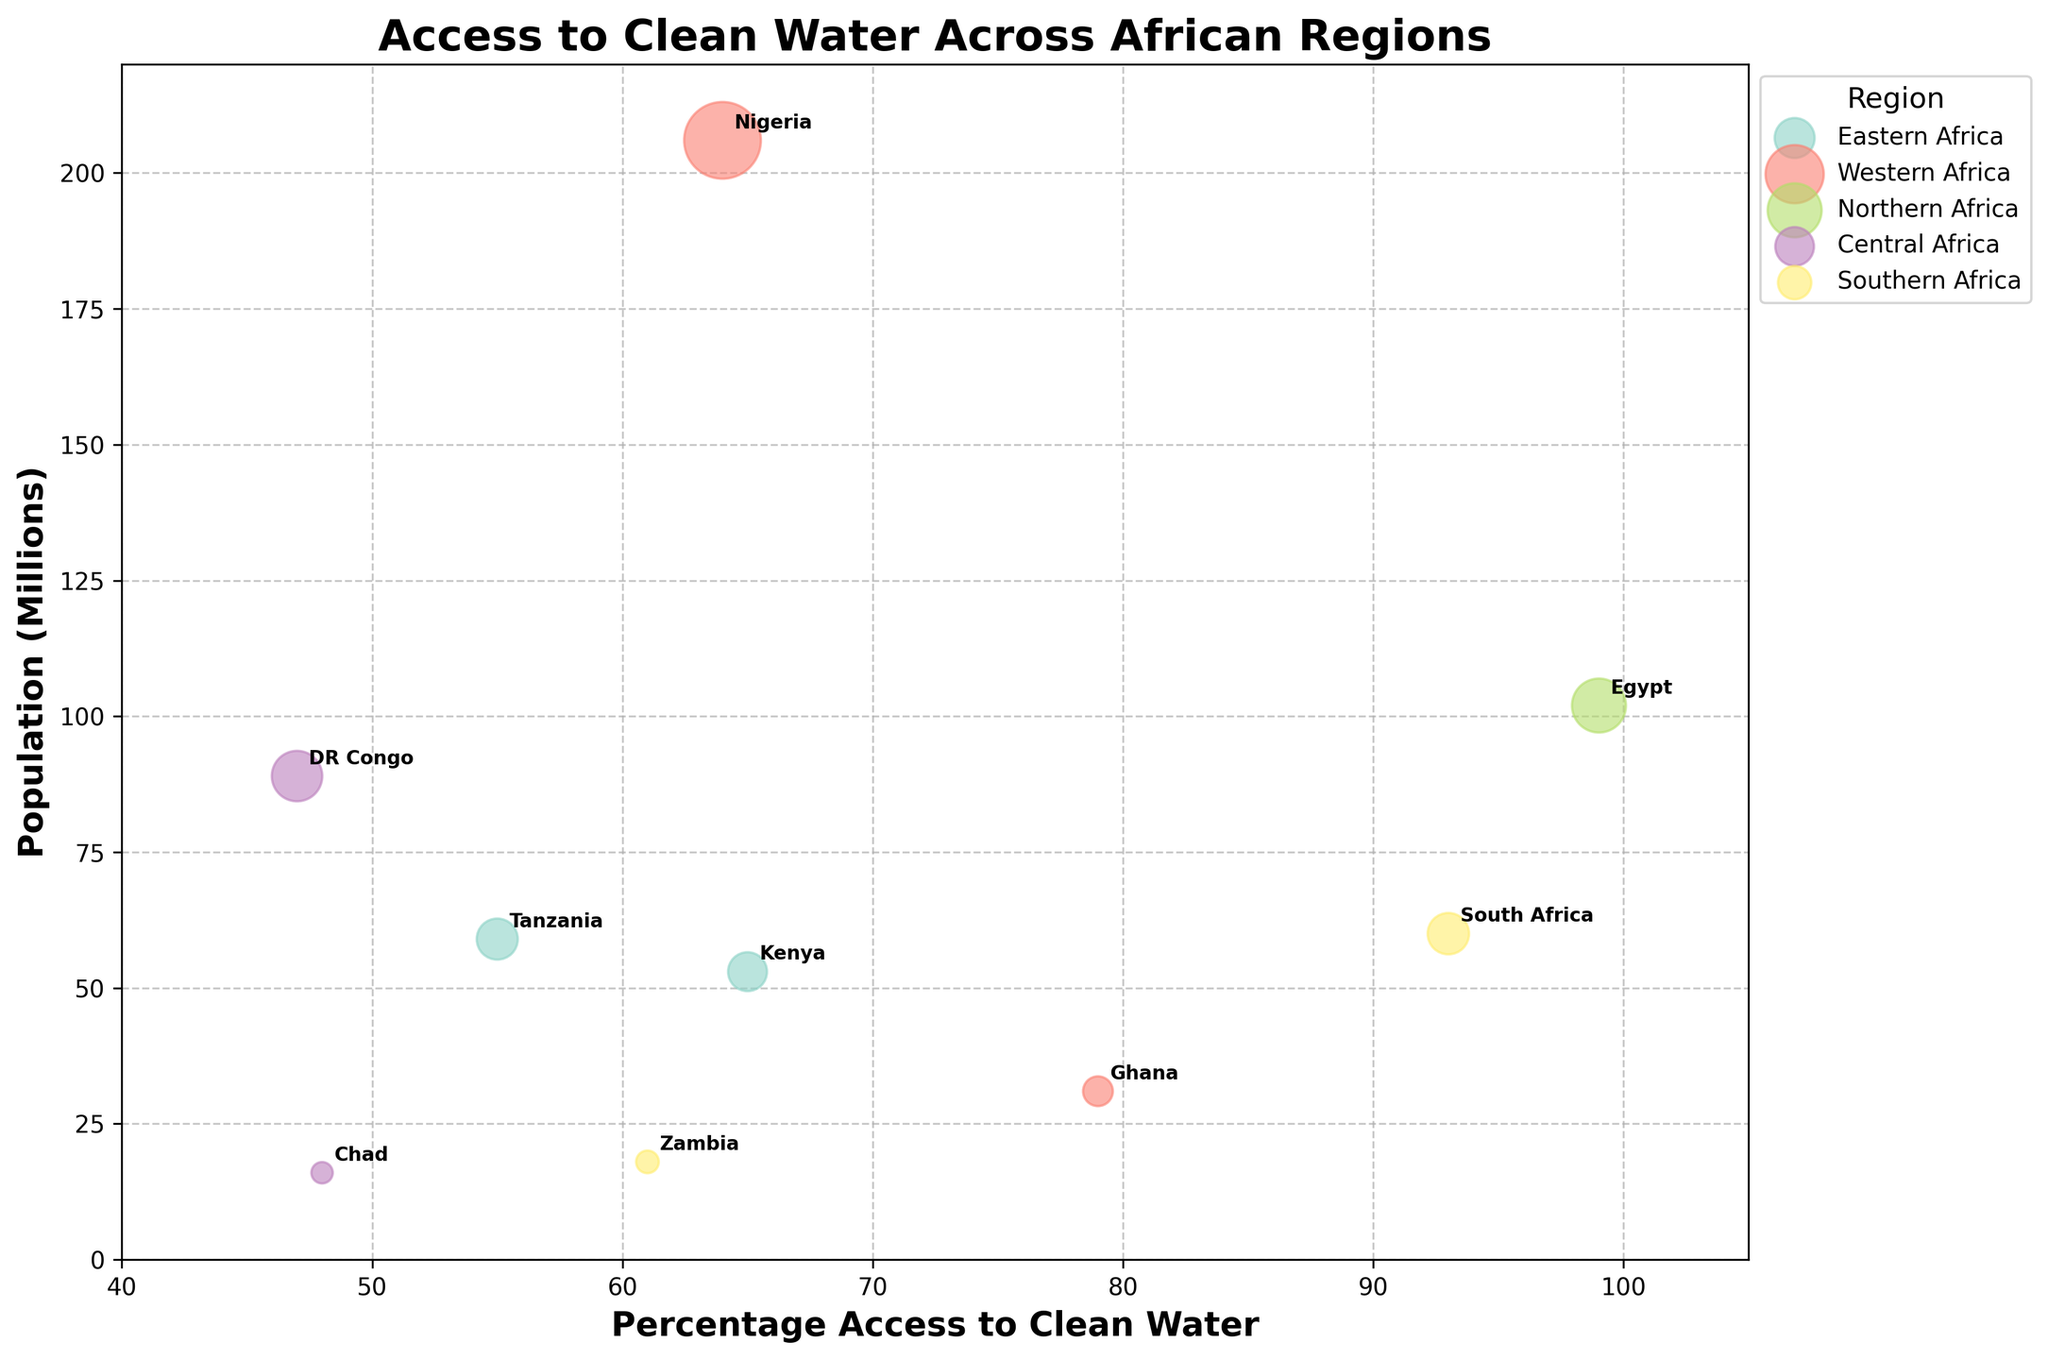What is the title of the figure? The title of the figure is found at the top of the chart, giving an overview of what the data represents. Here, it reads "Access to Clean Water Across African Regions."
Answer: Access to Clean Water Across African Regions How many regions are represented in the chart? By looking at the legend, you can see each distinct color represents a unique region. Counting the different regions listed, there are five.
Answer: Five Which country has the highest percentage of access to clean water? By locating the highest value on the x-axis (Percentage Access to Clean Water) and checking the corresponding bubble, Egypt has the highest value at 99%.
Answer: Egypt What is the population size of South Africa? Find the bubble labeled "South Africa" and read the corresponding y-axis value for Population (Millions), which is around 60 million.
Answer: 60 million Which two countries from Eastern Africa are shown? Look at the legend to identify the color for Eastern Africa, then find the corresponding bubbles. The countries are labeled as "Kenya" and "Tanzania."
Answer: Kenya and Tanzania What is the average percentage access to clean water in Western Africa? First, identify the countries in Western Africa: Nigeria (64) and Ghana (79). Add these percentages: 64 + 79 = 143. Then, divide by the number of countries: 143 / 2 = 71.5
Answer: 71.5% Which region has the lowest average access to clean water? Calculate the average for each region: 
Eastern Africa (65+55)/2 = 60;
Western Africa (64+79)/2 = 71.5;
Northern Africa (99);
Central Africa (48+47)/2 = 47.5;
Southern Africa (93+61)/2 = 77.
Among these, Central Africa has the lowest average (47.5).
Answer: Central Africa How is the size of the bubbles determined? The size of the bubbles corresponds to the Population in Millions for each country, with larger populations resulting in bigger bubbles. This helps visualize the population size relative to access to clean water.
Answer: By population size Which country in the Southern Africa region has higher access to clean water, and by how much? Compare Zambia (61%) and South Africa (93%). Subtract the smaller from the larger: 93 - 61 = 32. South Africa has higher access by 32%.
Answer: South Africa by 32% 